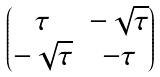Convert formula to latex. <formula><loc_0><loc_0><loc_500><loc_500>\begin{pmatrix} \tau & - \sqrt { \tau } \\ - \sqrt { \tau } & - \tau \end{pmatrix}</formula> 